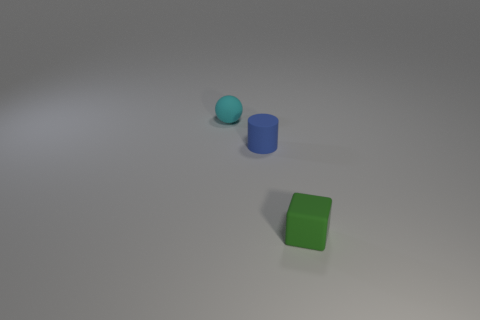Add 1 tiny cyan balls. How many objects exist? 4 Subtract all cylinders. How many objects are left? 2 Subtract 1 cyan spheres. How many objects are left? 2 Subtract all cyan matte balls. Subtract all tiny cyan spheres. How many objects are left? 1 Add 2 blue matte objects. How many blue matte objects are left? 3 Add 2 blue objects. How many blue objects exist? 3 